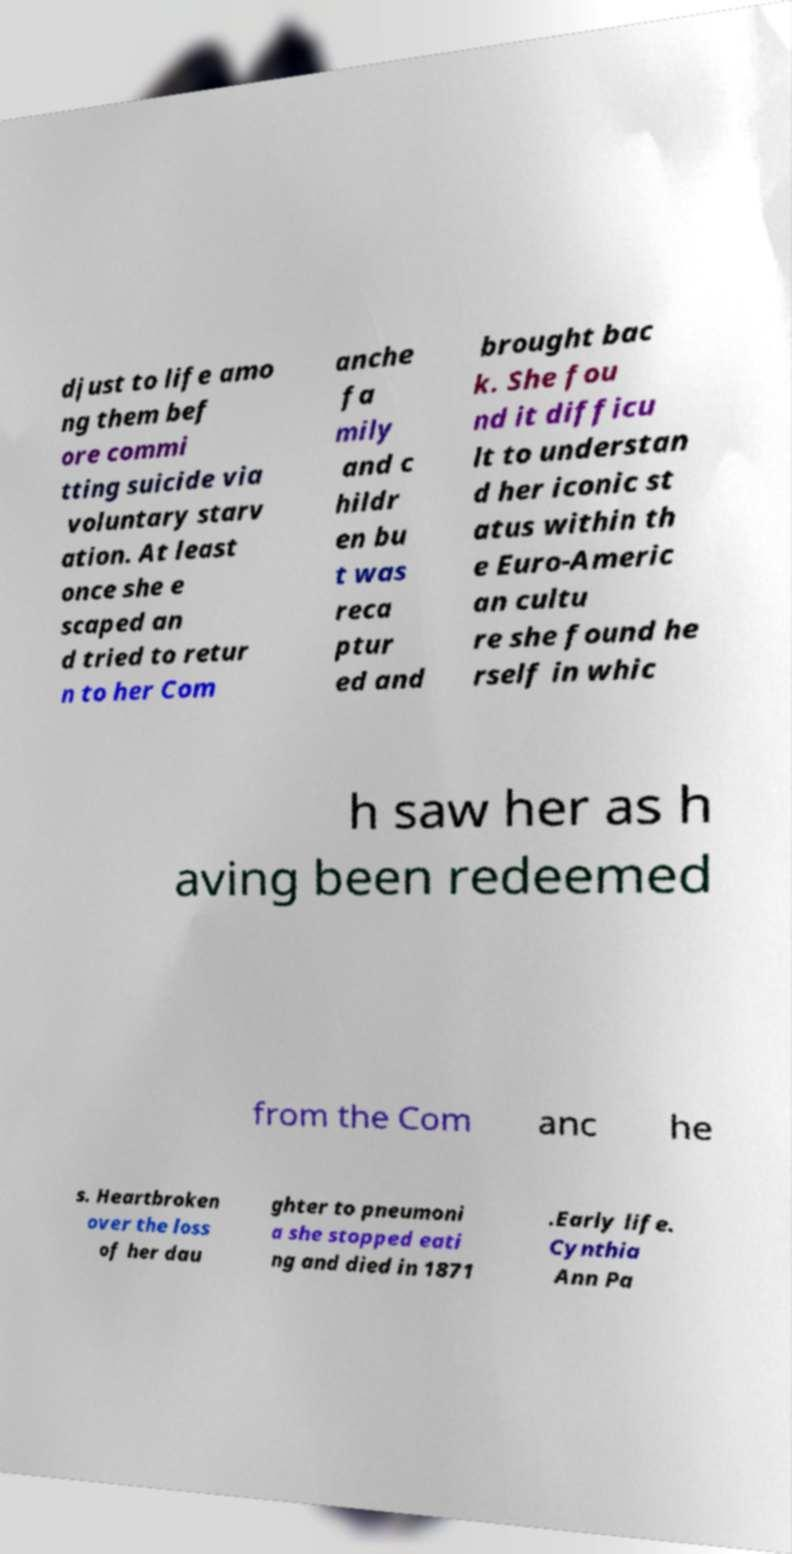What messages or text are displayed in this image? I need them in a readable, typed format. djust to life amo ng them bef ore commi tting suicide via voluntary starv ation. At least once she e scaped an d tried to retur n to her Com anche fa mily and c hildr en bu t was reca ptur ed and brought bac k. She fou nd it difficu lt to understan d her iconic st atus within th e Euro-Americ an cultu re she found he rself in whic h saw her as h aving been redeemed from the Com anc he s. Heartbroken over the loss of her dau ghter to pneumoni a she stopped eati ng and died in 1871 .Early life. Cynthia Ann Pa 